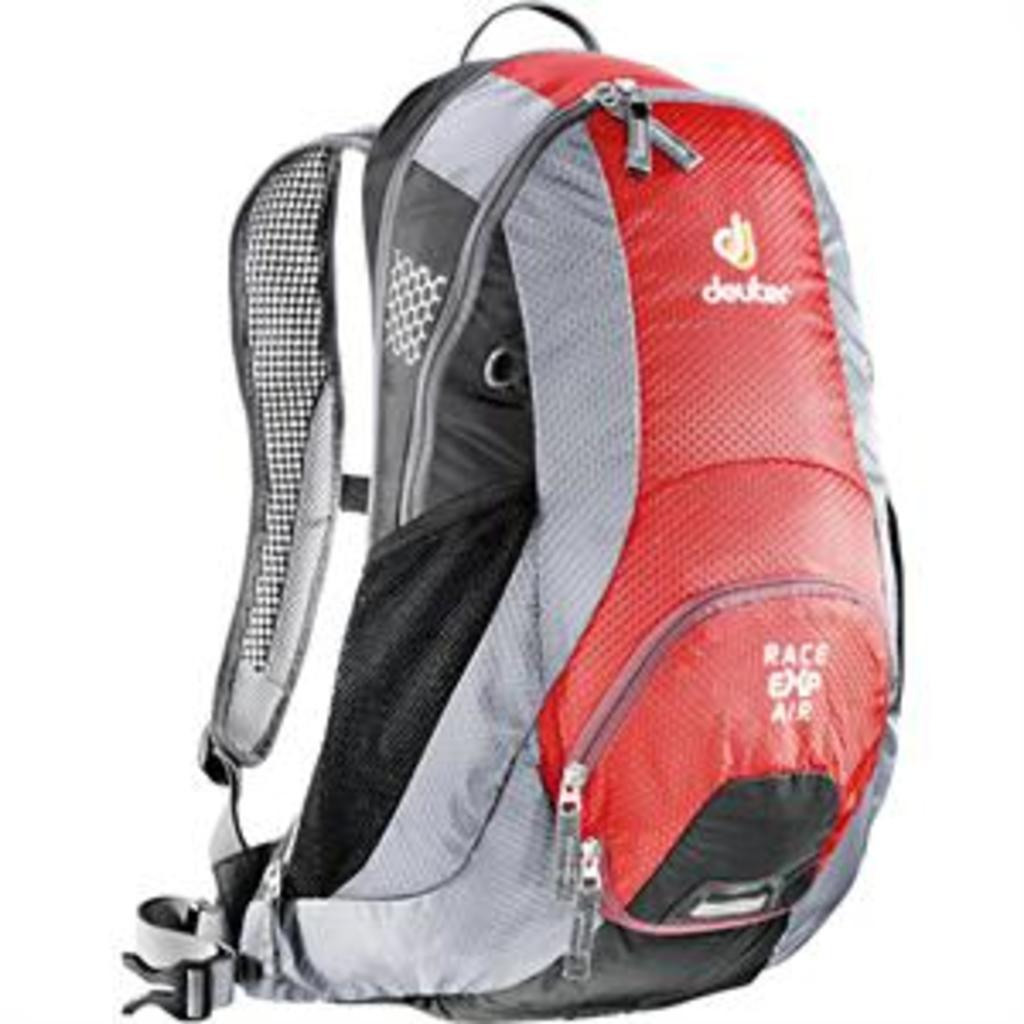What type of item is visible in the image? There is a backpack in the image. What feature does the backpack have for securing its contents? The backpack has a zip and a clip. Is there any branding or identification on the backpack? Yes, there is a logo on the backpack. What else can be seen in the image besides the backpack? There is some text visible in the image. Can you describe the event that is taking place in the image? There is no event taking place in the image; it simply shows a backpack with various features and some text. What type of example does the backpack provide in the image? The backpack itself is not an example of anything; it is just a backpack with specific features and a logo. 